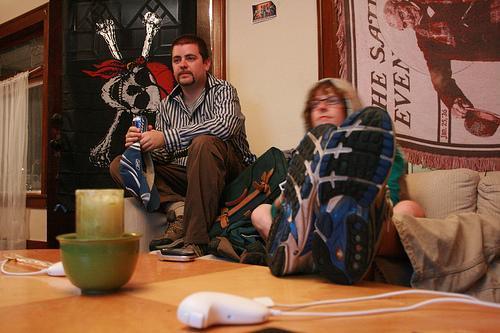How many people are there?
Give a very brief answer. 3. How many controllers are there?
Give a very brief answer. 2. How many men are in the pic?
Give a very brief answer. 2. How many Wii remotes can be seen?
Give a very brief answer. 2. 